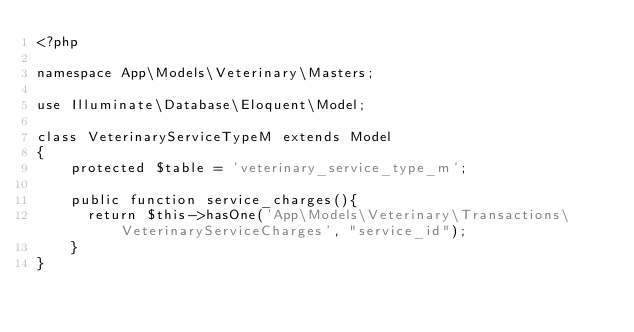Convert code to text. <code><loc_0><loc_0><loc_500><loc_500><_PHP_><?php

namespace App\Models\Veterinary\Masters;

use Illuminate\Database\Eloquent\Model;

class VeterinaryServiceTypeM extends Model
{
    protected $table = 'veterinary_service_type_m';

    public function service_charges(){
    	return $this->hasOne('App\Models\Veterinary\Transactions\VeterinaryServiceCharges', "service_id");
    } 
}
</code> 